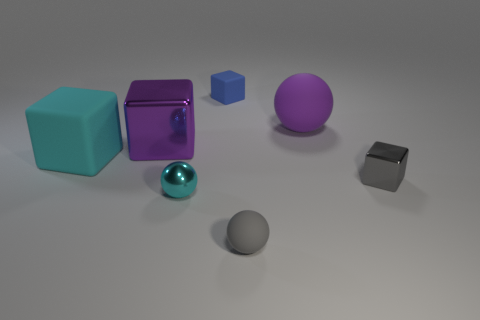There is a big matte object that is the same color as the large shiny cube; what shape is it? The large matte object sharing the color with the shiny cube is a sphere. Its matte surface contrasts with the reflective cube, making it an interesting study of how different textures can affect the perception of identical colors. 